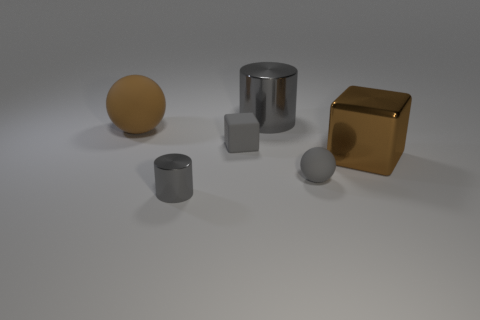Add 4 small cubes. How many objects exist? 10 Subtract all cylinders. How many objects are left? 4 Add 6 tiny things. How many tiny things are left? 9 Add 3 big gray shiny cylinders. How many big gray shiny cylinders exist? 4 Subtract 0 purple cylinders. How many objects are left? 6 Subtract all small blocks. Subtract all tiny gray metallic cylinders. How many objects are left? 4 